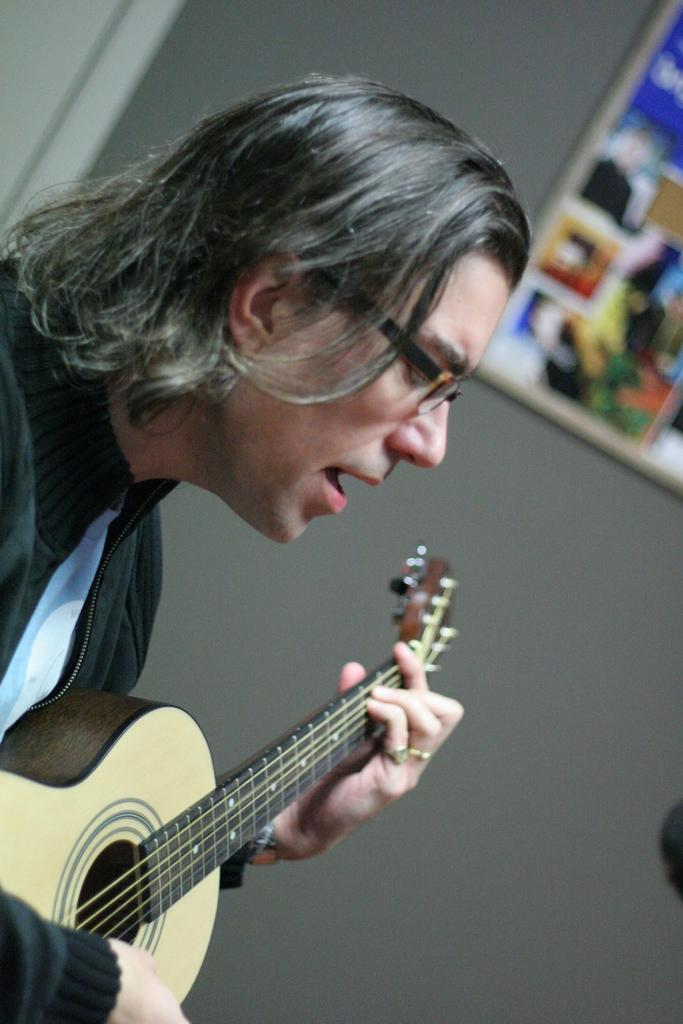What is the person in the image holding? The person is holding a guitar. What else can be seen in the image besides the person and the guitar? There is a frame and a grey wall visible in the image. How many girls are present in the image? There is no mention of girls in the image; it features a person holding a guitar. What type of story is being told in the image? There is no story being told in the image; it simply shows a person holding a guitar. 